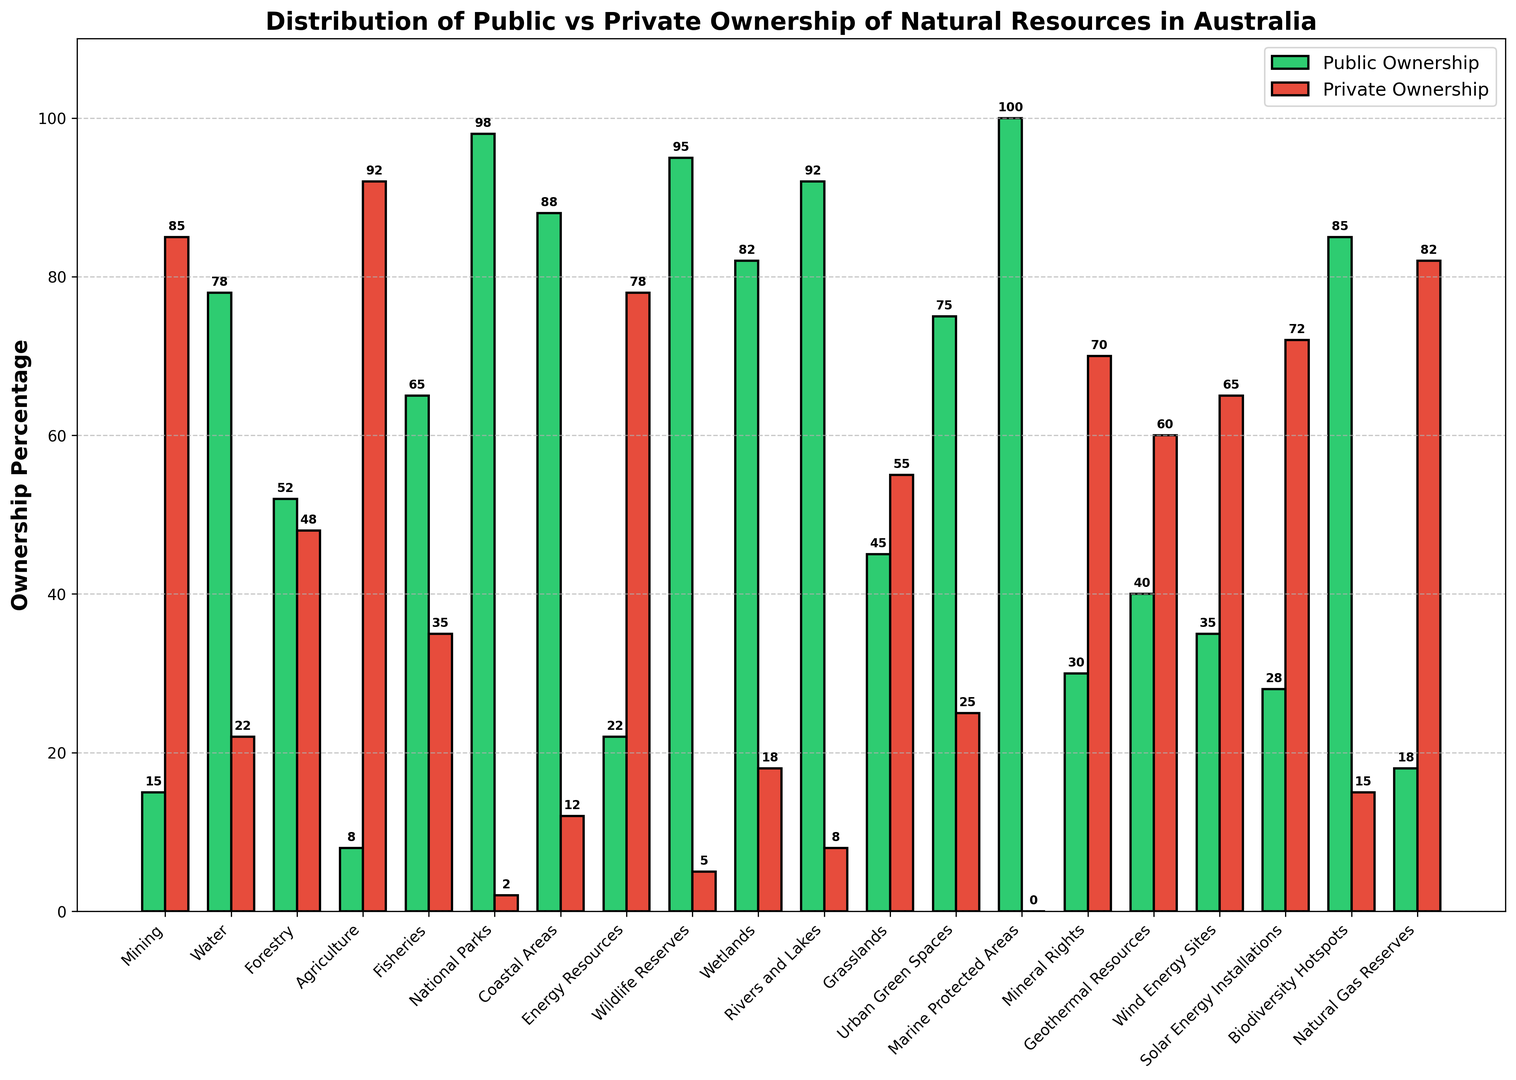Which sector has the highest percentage of public ownership? The "Marine Protected Areas" sector has a bar reaching 100% on the vertical axis, indicating it has full public ownership.
Answer: Marine Protected Areas Which sector has the greatest disparity between public and private ownership percentages? The "National Parks" sector shows the greatest disparity as its public ownership is 98%, and private ownership is just 2%. The difference is 96%.
Answer: National Parks What is the average public ownership percentage across all sectors? Sum all public ownership percentages and divide by the number of sectors. (15 + 78 + 52 + 8 + 65 + 98 + 88 + 22 + 95 + 82 + 92 + 45 + 75 + 100 + 30 + 40 + 35 + 28 + 85 + 18) / 20 = 1038 / 20 = 51.9
Answer: 51.9% Compare the public ownership percentages of "Water" and "Forestry"; which is higher and by how much? The public ownership of "Water" is 78%, and "Forestry" is 52%. The difference is 78 - 52 = 26%.
Answer: Water, by 26% Which two sectors have exactly opposite ownership ratios? The "Agriculture" sector (8% public, 92% private) and "Rivers and Lakes" (92% public, 8% private) have exactly opposite ownership ratios.
Answer: Agriculture and Rivers and Lakes Which sector has the lowest percentage of public ownership, and what is that percentage? The "Agriculture" sector has the lowest public ownership at 8%, as indicated by the shortest green bar.
Answer: Agriculture, 8% Is there any sector where the public ownership percentage is less than 20%? If so, name them. The sectors "Mining" (15%), "Agriculture" (8%), "Energy Resources" (22%), and "Natural Gas Reserves" (18%) all have public ownership of less than 20%.
Answer: Mining, Agriculture, Natural Gas Reserves For the "National Parks" sector, how much higher is the public ownership compared to private ownership? "National Parks" shows 98% public ownership and 2% private ownership. The difference is 98 - 2 = 96%.
Answer: 96% What is the median public ownership percentage among the listed sectors? Arrange the public ownership percentages in ascending order: 8, 15, 18, 22, 28, 30, 35, 40, 45, 52, 65, 75, 78, 82, 85, 88, 92, 95, 98, 100. The middle two numbers of the sorted list are 52 and 65. The median is (52 + 65) / 2 = 58.5.
Answer: 58.5 